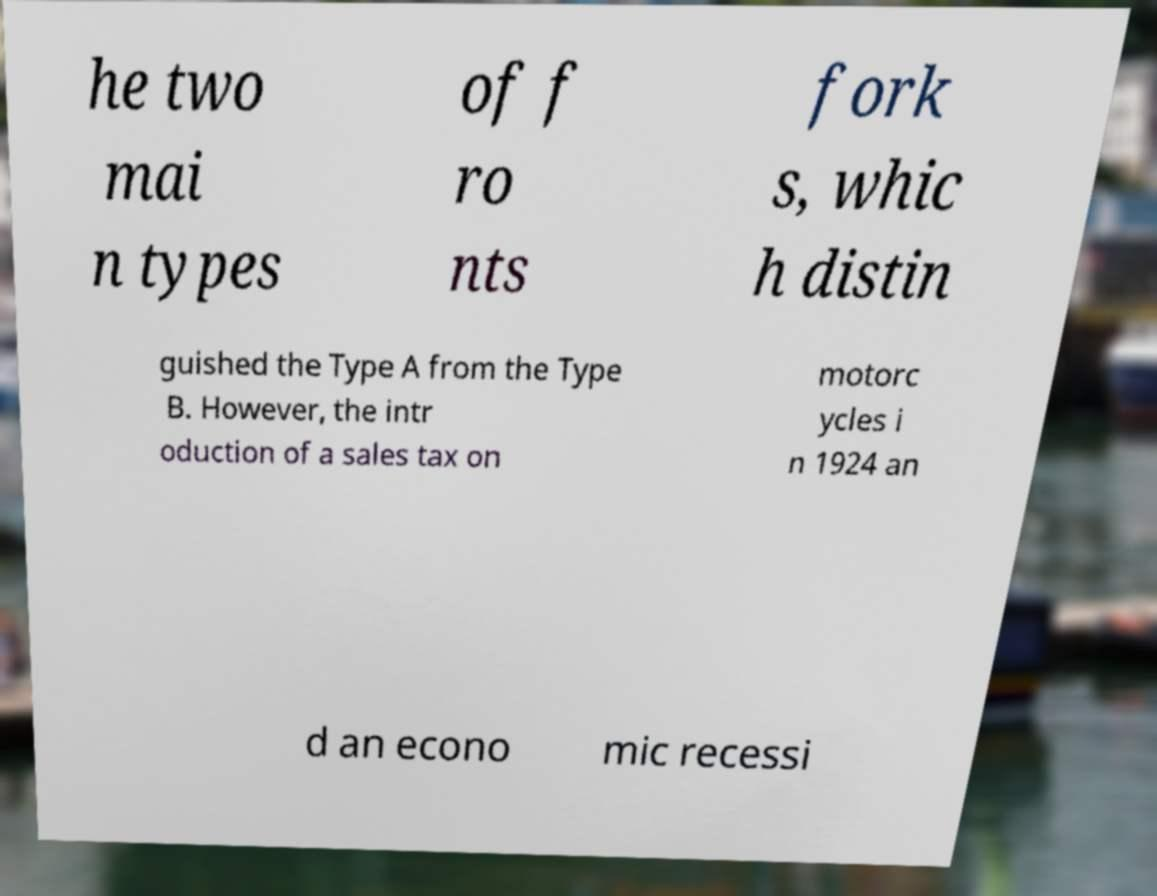For documentation purposes, I need the text within this image transcribed. Could you provide that? he two mai n types of f ro nts fork s, whic h distin guished the Type A from the Type B. However, the intr oduction of a sales tax on motorc ycles i n 1924 an d an econo mic recessi 